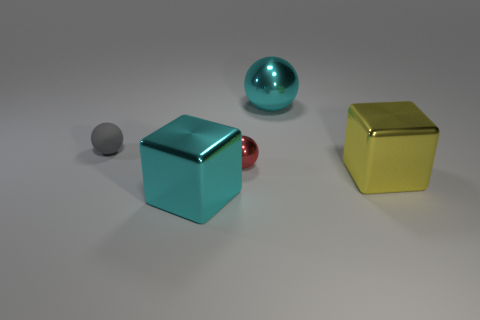Add 4 cyan blocks. How many objects exist? 9 Subtract all balls. How many objects are left? 2 Subtract 1 gray spheres. How many objects are left? 4 Subtract all red objects. Subtract all rubber spheres. How many objects are left? 3 Add 1 cyan shiny cubes. How many cyan shiny cubes are left? 2 Add 1 large red metallic things. How many large red metallic things exist? 1 